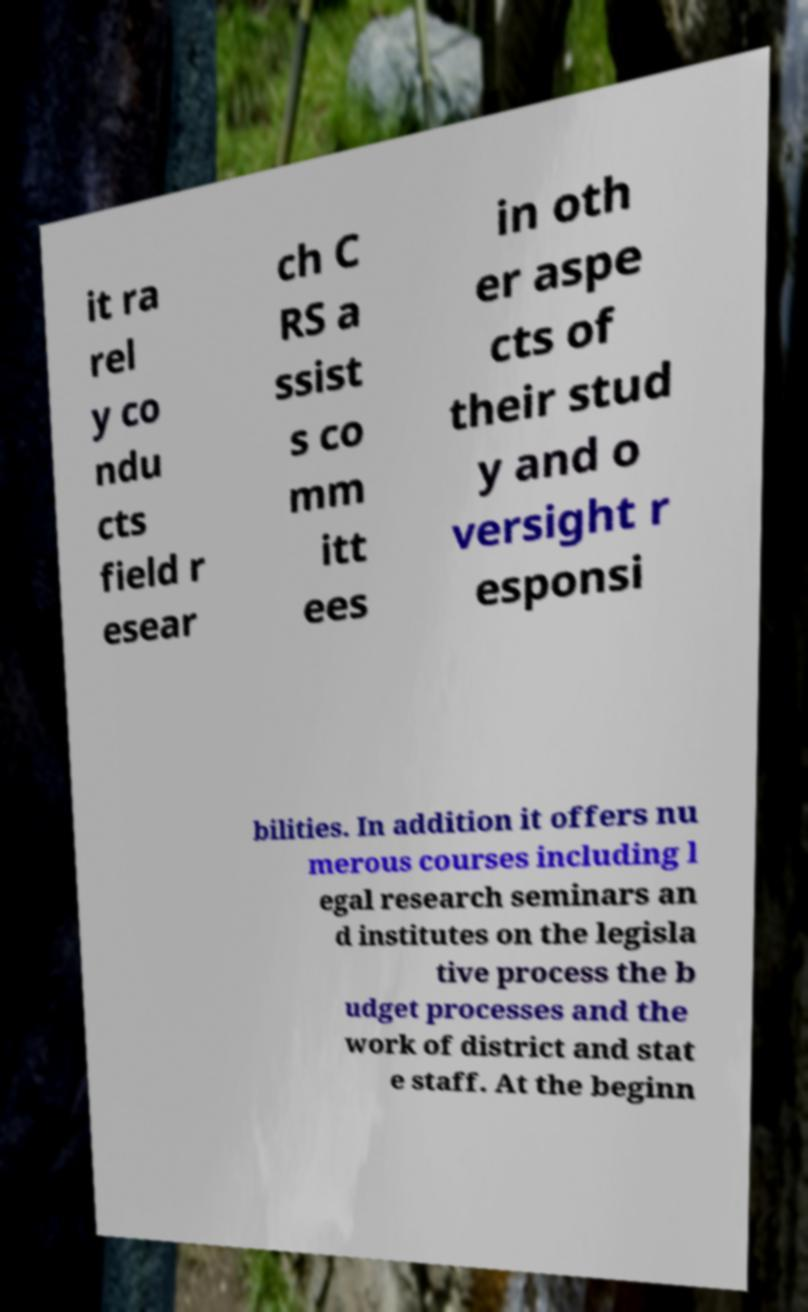Could you extract and type out the text from this image? it ra rel y co ndu cts field r esear ch C RS a ssist s co mm itt ees in oth er aspe cts of their stud y and o versight r esponsi bilities. In addition it offers nu merous courses including l egal research seminars an d institutes on the legisla tive process the b udget processes and the work of district and stat e staff. At the beginn 